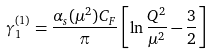Convert formula to latex. <formula><loc_0><loc_0><loc_500><loc_500>\gamma _ { 1 } ^ { ( 1 ) } = \frac { \alpha _ { s } ( \mu ^ { 2 } ) C _ { F } } { \pi } \left [ \ln \frac { Q ^ { 2 } } { \mu ^ { 2 } } - \frac { 3 } { 2 } \right ] \</formula> 